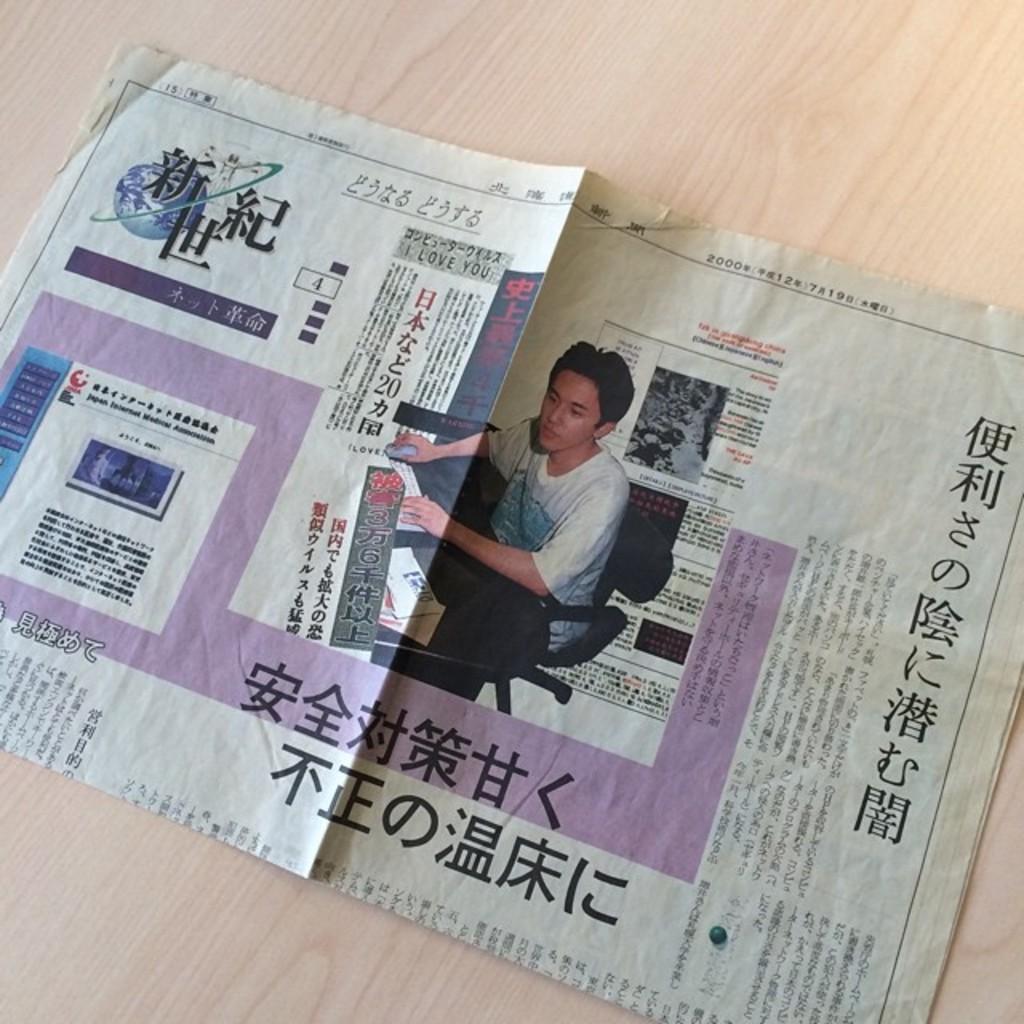Can you describe this image briefly? In this image we can see a newspaper on the table, there we can see a person's picture who is sitting on a chair and holding the mouse and some text in the newspaper. 